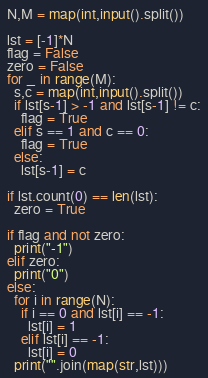Convert code to text. <code><loc_0><loc_0><loc_500><loc_500><_Python_>N,M = map(int,input().split())

lst = [-1]*N
flag = False
zero = False
for _ in range(M):
  s,c = map(int,input().split())
  if lst[s-1] > -1 and lst[s-1] != c:
    flag = True
  elif s == 1 and c == 0:
    flag = True
  else:
    lst[s-1] = c

if lst.count(0) == len(lst):
  zero = True
    
if flag and not zero:
  print("-1")
elif zero:
  print("0")
else:
  for i in range(N):
    if i == 0 and lst[i] == -1:
      lst[i] = 1
    elif lst[i] == -1:
      lst[i] = 0
  print("".join(map(str,lst)))</code> 